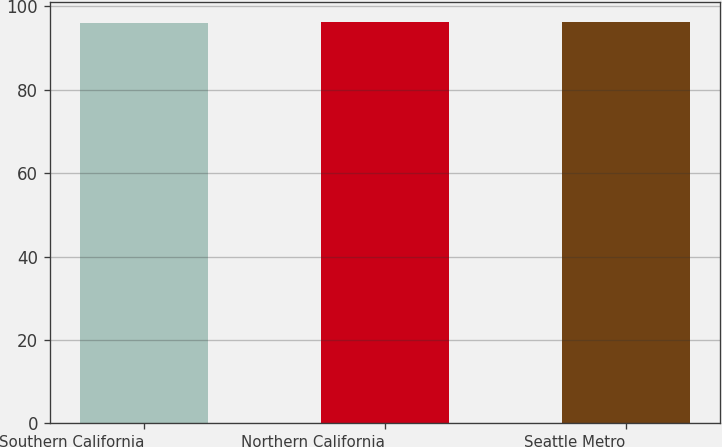<chart> <loc_0><loc_0><loc_500><loc_500><bar_chart><fcel>Southern California<fcel>Northern California<fcel>Seattle Metro<nl><fcel>96.1<fcel>96.2<fcel>96.3<nl></chart> 